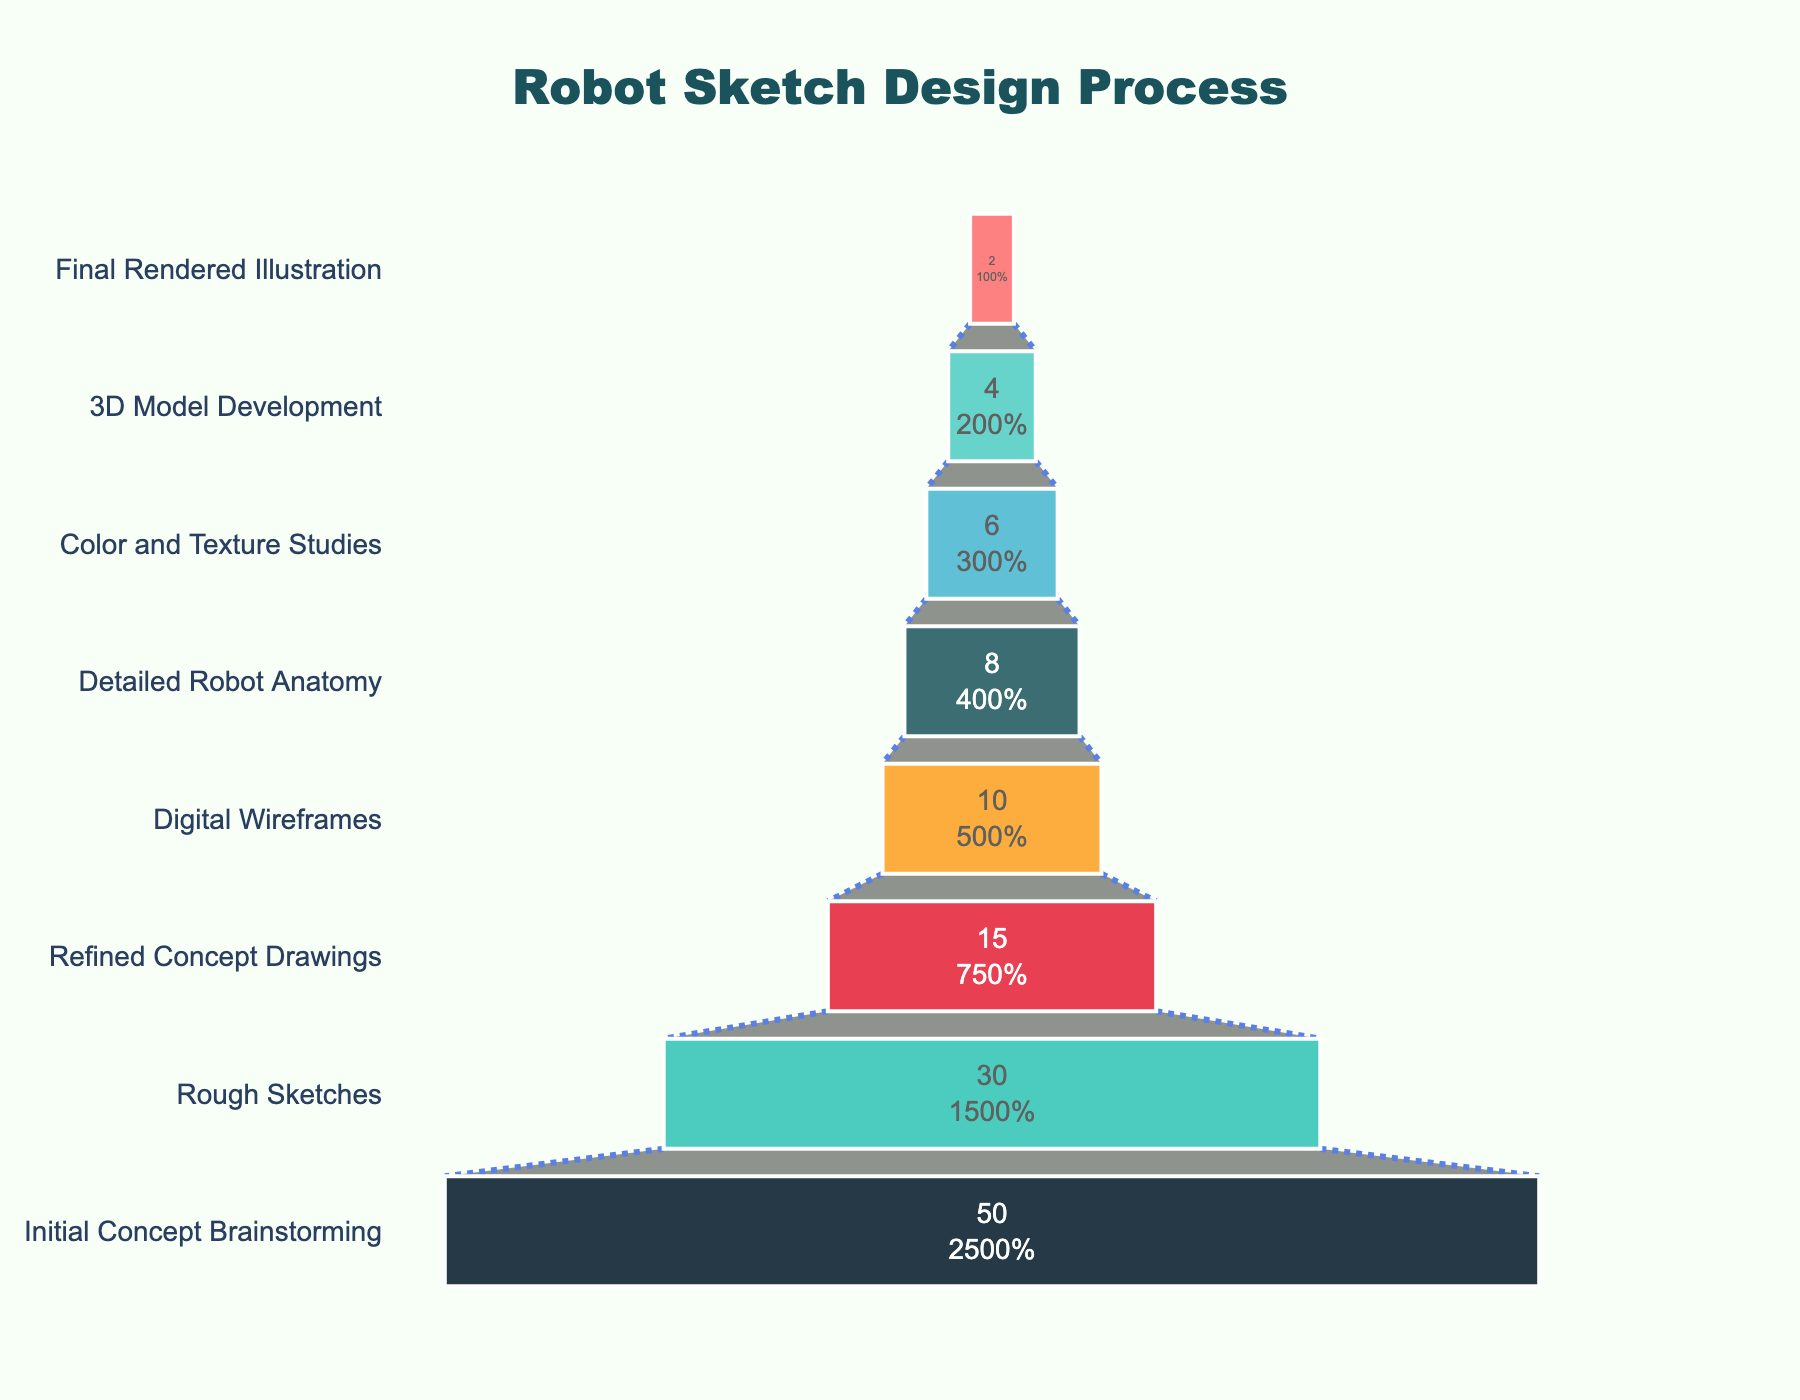How many stages are there in the robot sketch design process? Count the number of stages listed in the figure.
Answer: 8 What's the title of the figure? Look at the text at the top of the figure which denotes the main topic.
Answer: Robot Sketch Design Process Which stage has the lowest number of ideas/sketches? Identify the stage with the smallest number in the values along the funnel chart.
Answer: Final Rendered Illustration How many more ideas/sketches are there in the Rough Sketches stage compared to the Digital Wireframes stage? Subtract the number of ideas/sketches in Digital Wireframes from those in Rough Sketches (30 - 10).
Answer: 20 What percentage of the initial concepts remain after the Color and Texture Studies stage? Divide the number of Color and Texture Studies by Initial Concept Brainstorming (6/50), then multiply by 100 to get the percentage.
Answer: 12% Which stage has exactly half the number of ideas/sketches as the Refined Concept Drawings? Identify the stage that has half of the 15 ideas/sketches in Refined Concept Drawings (7.5), meaning the closest stage is 3D Model Development with 4 ideas/sketches.
Answer: 3D Model Development How do the numbers of Rough Sketches compare to the Detailed Robot Anatomy sketches? Examine and compare the values of Rough Sketches (30) and Detailed Robot Anatomy (8), noticing which is greater or how many times greater Rough Sketches are compared to Detailed Robot Anatomy (30/8).
Answer: 3.75 times more If the stages of 3D Model Development and Final Rendered Illustration are combined, what would be the new number of ideas/sketches? Add the values of 3D Model Development and Final Rendered Illustration (4 + 2).
Answer: 6 What’s the difference in the number of ideas/sketches between the stages with the highest and lowest values? Subtract the lowest value is from the highest value (50 - 2).
Answer: 48 What color represents the Initial Concept Brainstorming stage in the funnel chart? Identify the color associated with the Initial Concept Brainstorming stage on the funnel chart.
Answer: Red (assumed based on the typical color associations but may vary) 